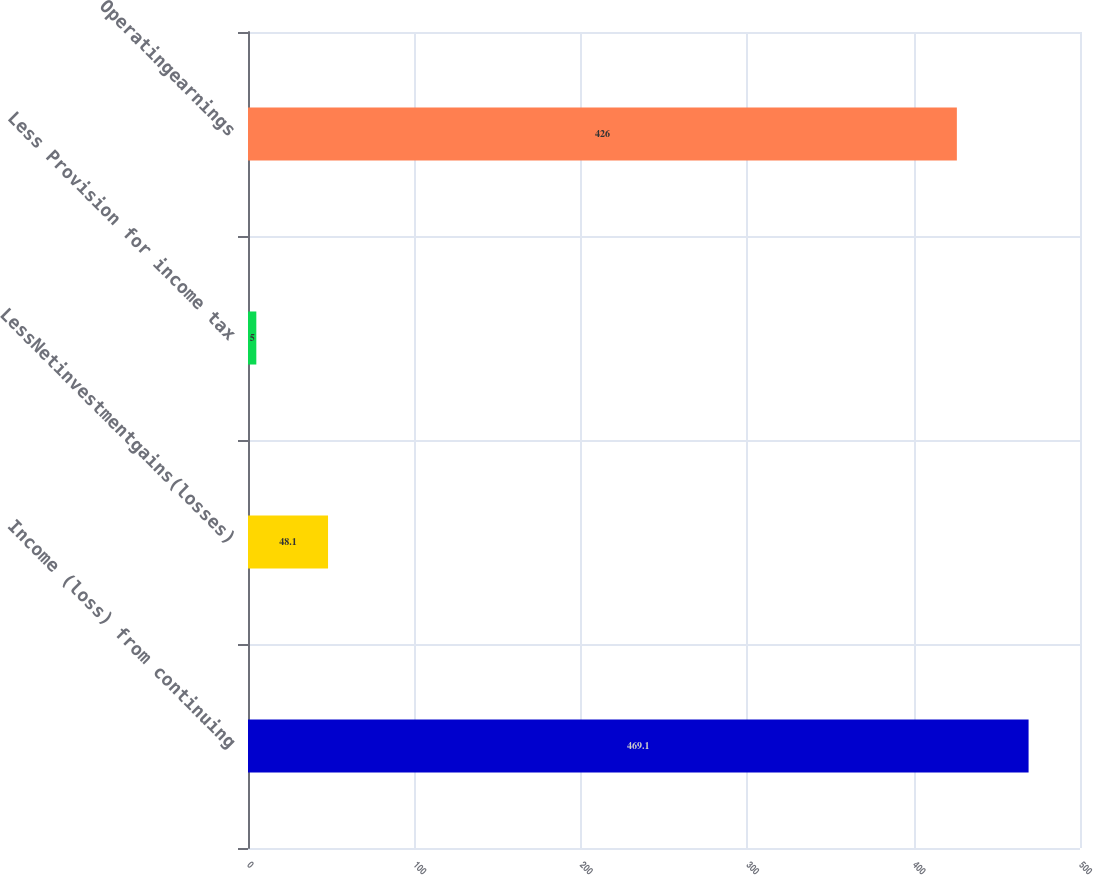Convert chart. <chart><loc_0><loc_0><loc_500><loc_500><bar_chart><fcel>Income (loss) from continuing<fcel>LessNetinvestmentgains(losses)<fcel>Less Provision for income tax<fcel>Operatingearnings<nl><fcel>469.1<fcel>48.1<fcel>5<fcel>426<nl></chart> 